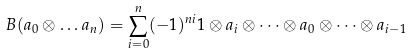Convert formula to latex. <formula><loc_0><loc_0><loc_500><loc_500>B ( a _ { 0 } \otimes \dots a _ { n } ) = \sum _ { i = 0 } ^ { n } ( - 1 ) ^ { n i } 1 \otimes a _ { i } \otimes \dots \otimes a _ { 0 } \otimes \dots \otimes a _ { i - 1 }</formula> 